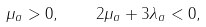Convert formula to latex. <formula><loc_0><loc_0><loc_500><loc_500>\mu _ { a } > 0 , \quad 2 \mu _ { a } + 3 \lambda _ { a } < 0 ,</formula> 